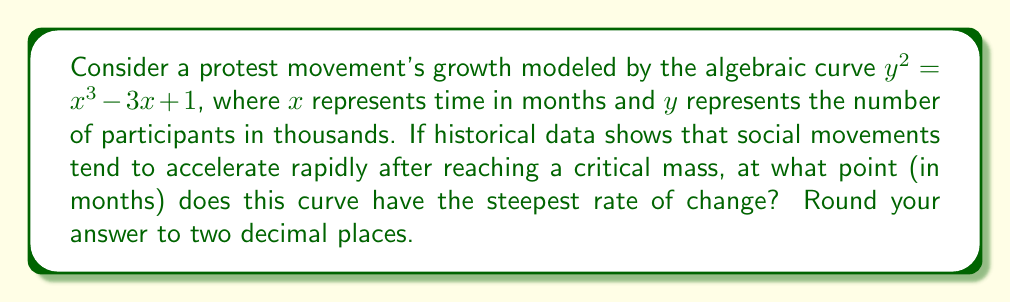Show me your answer to this math problem. To find the point where the curve has the steepest rate of change, we need to follow these steps:

1) First, we need to find the derivative of the curve. Since the curve is given implicitly, we'll use implicit differentiation:

   $2y\frac{dy}{dx} = 3x^2 - 3$

2) Solve for $\frac{dy}{dx}$:

   $\frac{dy}{dx} = \frac{3x^2 - 3}{2y}$

3) The steepest rate of change occurs where $\frac{d^2y}{dx^2} = 0$. To find this, we need to differentiate $\frac{dy}{dx}$ again:

   $\frac{d^2y}{dx^2} = \frac{(6x)(2y) - (3x^2 - 3)(2\frac{dy}{dx})}{4y^2}$

4) Substitute $\frac{dy}{dx} = \frac{3x^2 - 3}{2y}$ into this equation:

   $\frac{d^2y}{dx^2} = \frac{12xy - (3x^2 - 3)(\frac{3x^2 - 3}{y})}{4y^2}$

5) Set this equal to zero and simplify:

   $12xy - \frac{(3x^2 - 3)^2}{y} = 0$

6) Multiply both sides by $y$:

   $12xy^2 - (3x^2 - 3)^2 = 0$

7) Substitute $y^2 = x^3 - 3x + 1$:

   $12x(x^3 - 3x + 1) - (3x^2 - 3)^2 = 0$

8) Expand and simplify:

   $12x^4 - 36x^2 + 12x - 9x^4 + 18x^2 - 9 = 0$
   $3x^4 - 18x^2 + 12x - 9 = 0$

9) This is a 4th degree polynomial equation. It can be solved numerically. Using a numerical solver, we find that the real solutions are approximately $x ≈ -1.73$ and $x ≈ 1.00$.

10) Since time cannot be negative in this context, we take the positive solution: $x ≈ 1.00$.

Therefore, the curve has the steepest rate of change at approximately 1.00 months.
Answer: 1.00 months 